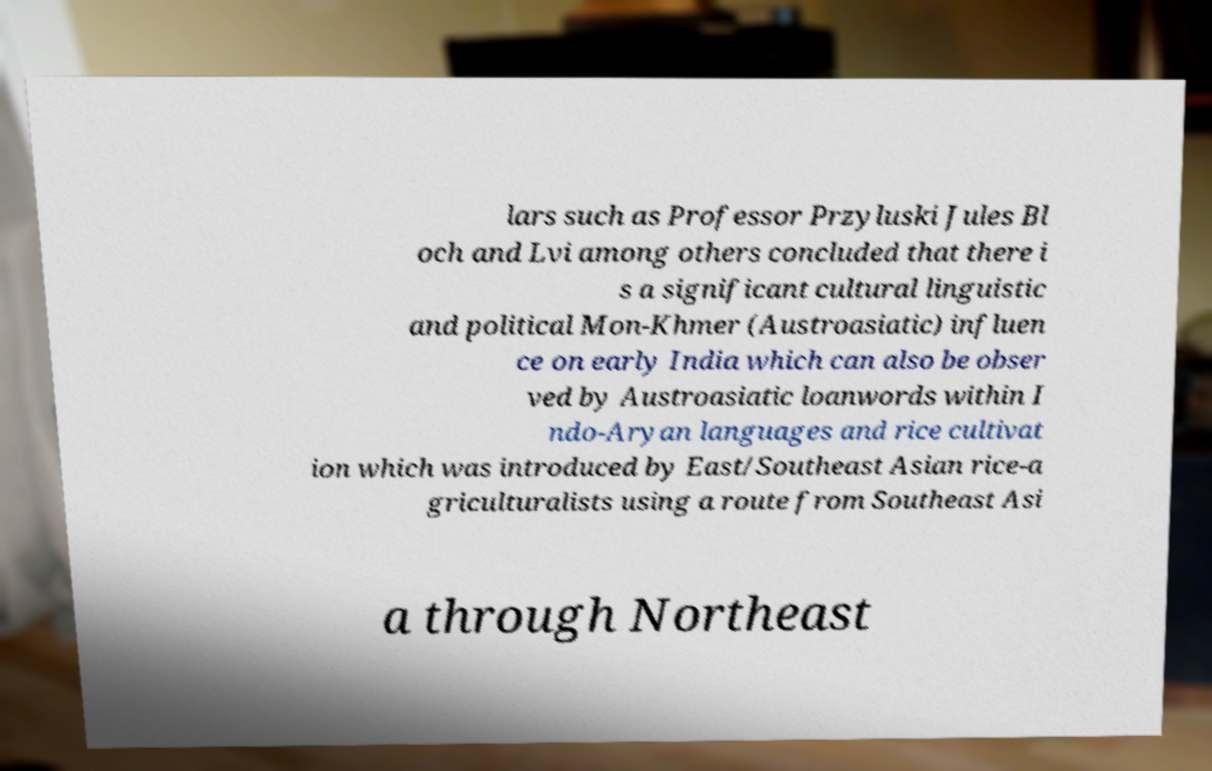Please identify and transcribe the text found in this image. lars such as Professor Przyluski Jules Bl och and Lvi among others concluded that there i s a significant cultural linguistic and political Mon-Khmer (Austroasiatic) influen ce on early India which can also be obser ved by Austroasiatic loanwords within I ndo-Aryan languages and rice cultivat ion which was introduced by East/Southeast Asian rice-a griculturalists using a route from Southeast Asi a through Northeast 